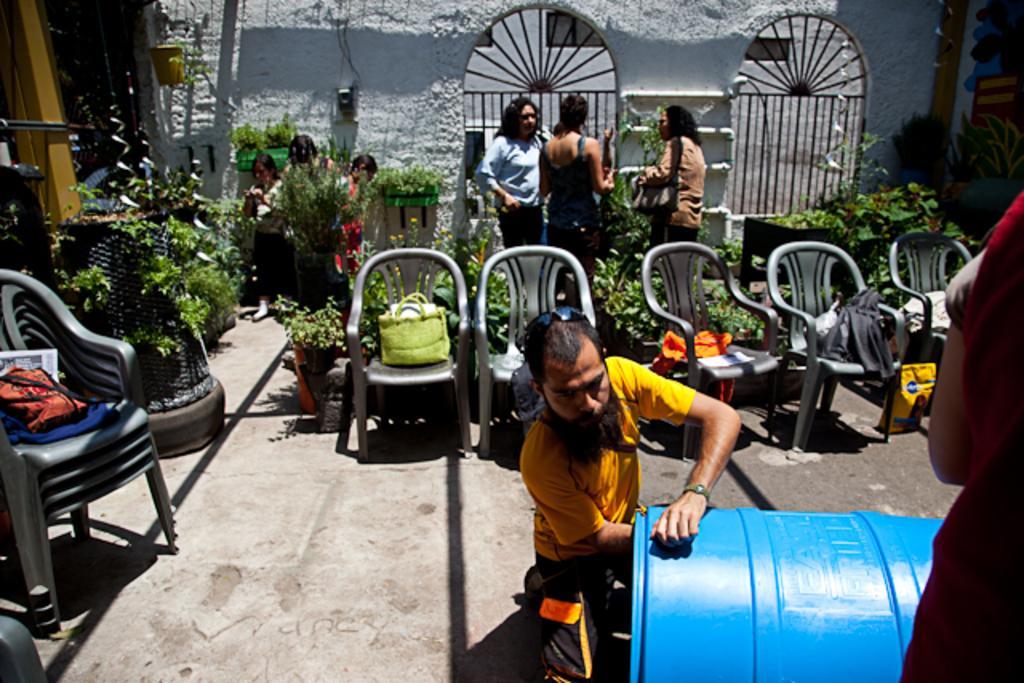Can you describe this image briefly? In this image there are group of persons sitting and standing and at the foreground of the image there is a person cleaning the drum and at the background of the image there are plants and wall. 